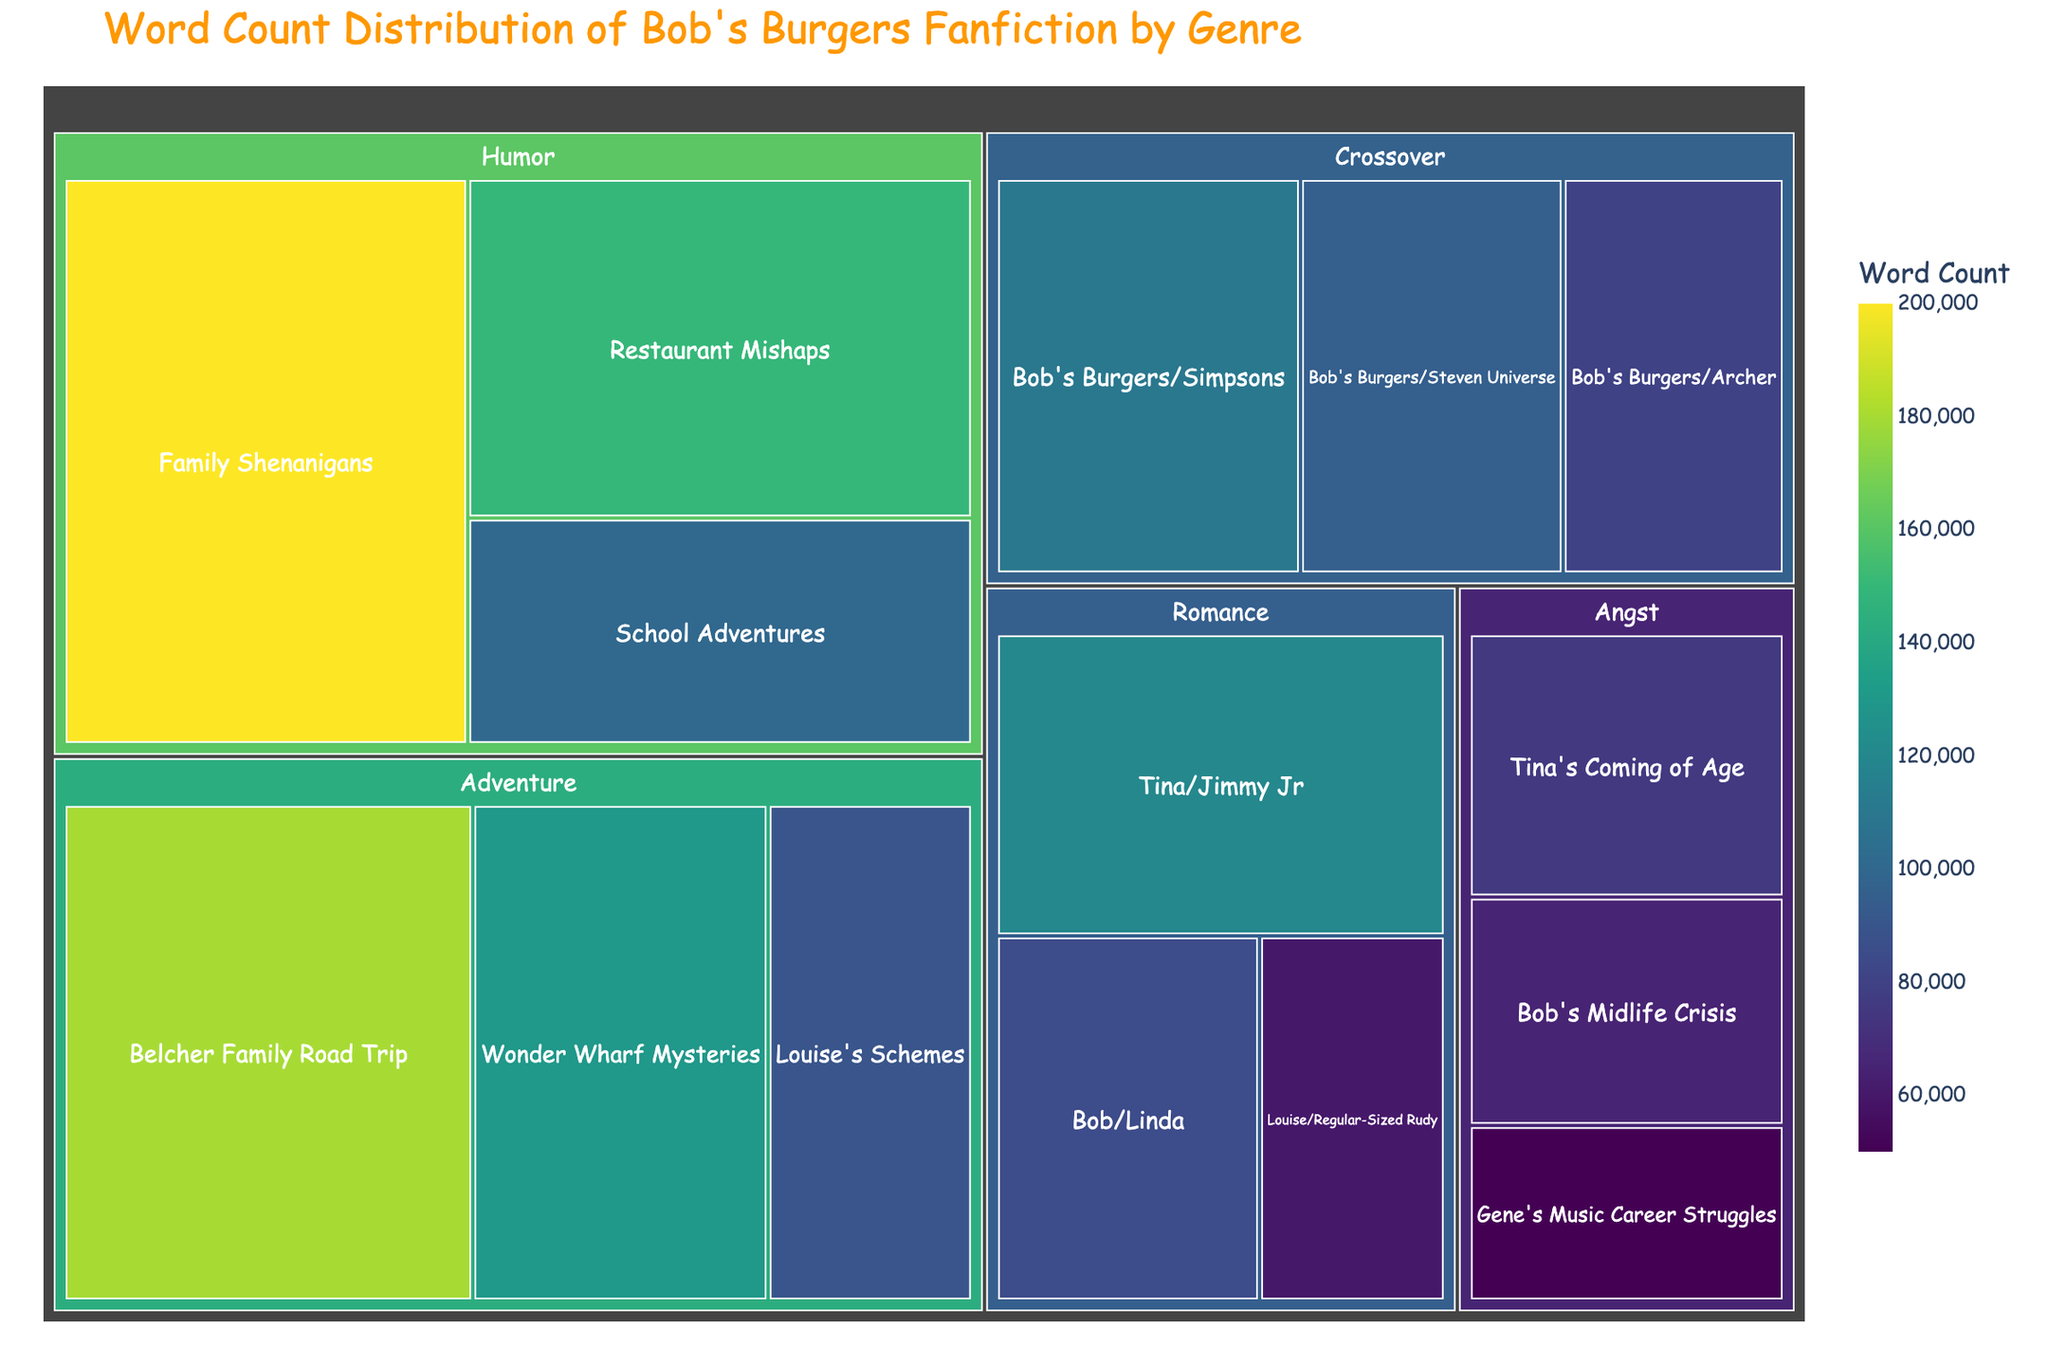What is the title of the treemap? The title is located at the top of the figure and provides a summary of the information presented in the chart.
Answer: Word Count Distribution of Bob's Burgers Fanfiction by Genre Which subgenre in the "Romance" genre has the highest word count? To find this, we look at the "Romance" genre section of the treemap and compare the word count values of its subgenres.
Answer: Tina/Jimmy Jr How many genres are represented in the treemap? Count the number of distinct "genre" labels at the first level of the treemap hierarchy.
Answer: 5 What is the total word count for the "Humor" genre? Sum up the word counts of all subgenres under the "Humor" genre: 200,000 + 150,000 + 100,000.
Answer: 450,000 Which genre has the smallest total word count, and what is it? Calculate the total word counts for each genre and compare them to find the smallest: "Romance" (265,000), "Humor" (450,000), "Adventure" (400,000), "Angst" (190,000), "Crossover" (285,000).
Answer: Angst What is the difference in word count between "Belcher Family Road Trip" and "Restaurant Mishaps"? Subtract the word count of "Restaurant Mishaps" from that of "Belcher Family Road Trip": 180,000 - 150,000.
Answer: 30,000 Which "Crossover" subgenre has the least word count? To find this, we check the word counts of all subgenres under the "Crossover" genre and identify the smallest one.
Answer: Bob's Burgers/Archer Compare the total word counts of the "Adventure" and "Crossover" genres. Which is greater? Calculate and compare the totals for each genre: "Adventure" (180,000 + 130,000 + 90,000) and "Crossover" (110,000 + 95,000 + 80,000).
Answer: Adventure What percentage of the total "Romance" genre word count comes from the "Tina/Jimmy Jr" subgenre? Calculate the percentage using the word counts: (120,000 / 265,000) * 100.
Answer: Approximately 45.3% Find the subgenre with the highest word count in the entire treemap. Identify the highest word count value among all subgenres across all genres in the treemap and find the corresponding subgenre.
Answer: Family Shenanigans 